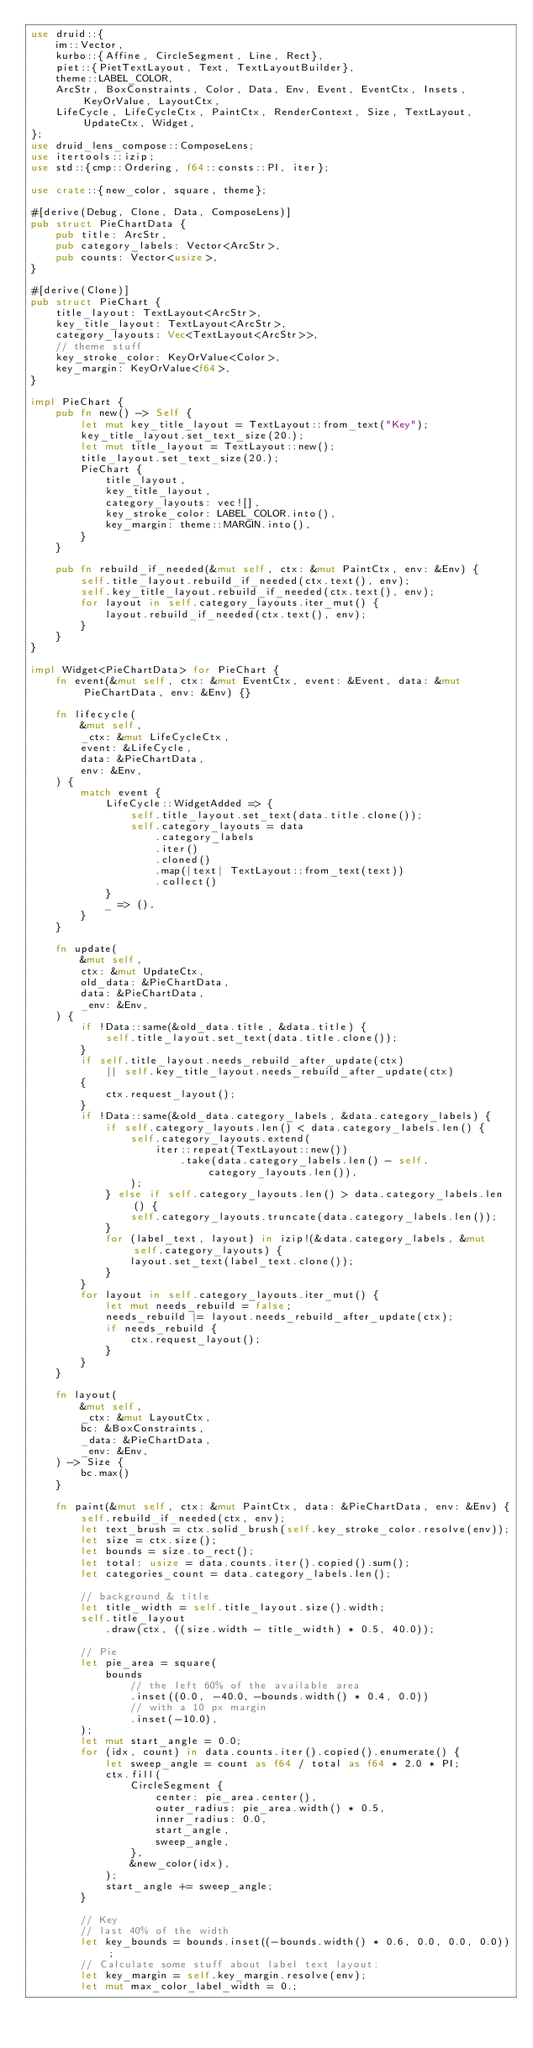<code> <loc_0><loc_0><loc_500><loc_500><_Rust_>use druid::{
    im::Vector,
    kurbo::{Affine, CircleSegment, Line, Rect},
    piet::{PietTextLayout, Text, TextLayoutBuilder},
    theme::LABEL_COLOR,
    ArcStr, BoxConstraints, Color, Data, Env, Event, EventCtx, Insets, KeyOrValue, LayoutCtx,
    LifeCycle, LifeCycleCtx, PaintCtx, RenderContext, Size, TextLayout, UpdateCtx, Widget,
};
use druid_lens_compose::ComposeLens;
use itertools::izip;
use std::{cmp::Ordering, f64::consts::PI, iter};

use crate::{new_color, square, theme};

#[derive(Debug, Clone, Data, ComposeLens)]
pub struct PieChartData {
    pub title: ArcStr,
    pub category_labels: Vector<ArcStr>,
    pub counts: Vector<usize>,
}

#[derive(Clone)]
pub struct PieChart {
    title_layout: TextLayout<ArcStr>,
    key_title_layout: TextLayout<ArcStr>,
    category_layouts: Vec<TextLayout<ArcStr>>,
    // theme stuff
    key_stroke_color: KeyOrValue<Color>,
    key_margin: KeyOrValue<f64>,
}

impl PieChart {
    pub fn new() -> Self {
        let mut key_title_layout = TextLayout::from_text("Key");
        key_title_layout.set_text_size(20.);
        let mut title_layout = TextLayout::new();
        title_layout.set_text_size(20.);
        PieChart {
            title_layout,
            key_title_layout,
            category_layouts: vec![],
            key_stroke_color: LABEL_COLOR.into(),
            key_margin: theme::MARGIN.into(),
        }
    }

    pub fn rebuild_if_needed(&mut self, ctx: &mut PaintCtx, env: &Env) {
        self.title_layout.rebuild_if_needed(ctx.text(), env);
        self.key_title_layout.rebuild_if_needed(ctx.text(), env);
        for layout in self.category_layouts.iter_mut() {
            layout.rebuild_if_needed(ctx.text(), env);
        }
    }
}

impl Widget<PieChartData> for PieChart {
    fn event(&mut self, ctx: &mut EventCtx, event: &Event, data: &mut PieChartData, env: &Env) {}

    fn lifecycle(
        &mut self,
        _ctx: &mut LifeCycleCtx,
        event: &LifeCycle,
        data: &PieChartData,
        env: &Env,
    ) {
        match event {
            LifeCycle::WidgetAdded => {
                self.title_layout.set_text(data.title.clone());
                self.category_layouts = data
                    .category_labels
                    .iter()
                    .cloned()
                    .map(|text| TextLayout::from_text(text))
                    .collect()
            }
            _ => (),
        }
    }

    fn update(
        &mut self,
        ctx: &mut UpdateCtx,
        old_data: &PieChartData,
        data: &PieChartData,
        _env: &Env,
    ) {
        if !Data::same(&old_data.title, &data.title) {
            self.title_layout.set_text(data.title.clone());
        }
        if self.title_layout.needs_rebuild_after_update(ctx)
            || self.key_title_layout.needs_rebuild_after_update(ctx)
        {
            ctx.request_layout();
        }
        if !Data::same(&old_data.category_labels, &data.category_labels) {
            if self.category_layouts.len() < data.category_labels.len() {
                self.category_layouts.extend(
                    iter::repeat(TextLayout::new())
                        .take(data.category_labels.len() - self.category_layouts.len()),
                );
            } else if self.category_layouts.len() > data.category_labels.len() {
                self.category_layouts.truncate(data.category_labels.len());
            }
            for (label_text, layout) in izip!(&data.category_labels, &mut self.category_layouts) {
                layout.set_text(label_text.clone());
            }
        }
        for layout in self.category_layouts.iter_mut() {
            let mut needs_rebuild = false;
            needs_rebuild |= layout.needs_rebuild_after_update(ctx);
            if needs_rebuild {
                ctx.request_layout();
            }
        }
    }

    fn layout(
        &mut self,
        _ctx: &mut LayoutCtx,
        bc: &BoxConstraints,
        _data: &PieChartData,
        _env: &Env,
    ) -> Size {
        bc.max()
    }

    fn paint(&mut self, ctx: &mut PaintCtx, data: &PieChartData, env: &Env) {
        self.rebuild_if_needed(ctx, env);
        let text_brush = ctx.solid_brush(self.key_stroke_color.resolve(env));
        let size = ctx.size();
        let bounds = size.to_rect();
        let total: usize = data.counts.iter().copied().sum();
        let categories_count = data.category_labels.len();

        // background & title
        let title_width = self.title_layout.size().width;
        self.title_layout
            .draw(ctx, ((size.width - title_width) * 0.5, 40.0));

        // Pie
        let pie_area = square(
            bounds
                // the left 60% of the available area
                .inset((0.0, -40.0, -bounds.width() * 0.4, 0.0))
                // with a 10 px margin
                .inset(-10.0),
        );
        let mut start_angle = 0.0;
        for (idx, count) in data.counts.iter().copied().enumerate() {
            let sweep_angle = count as f64 / total as f64 * 2.0 * PI;
            ctx.fill(
                CircleSegment {
                    center: pie_area.center(),
                    outer_radius: pie_area.width() * 0.5,
                    inner_radius: 0.0,
                    start_angle,
                    sweep_angle,
                },
                &new_color(idx),
            );
            start_angle += sweep_angle;
        }

        // Key
        // last 40% of the width
        let key_bounds = bounds.inset((-bounds.width() * 0.6, 0.0, 0.0, 0.0));
        // Calculate some stuff about label text layout:
        let key_margin = self.key_margin.resolve(env);
        let mut max_color_label_width = 0.;</code> 